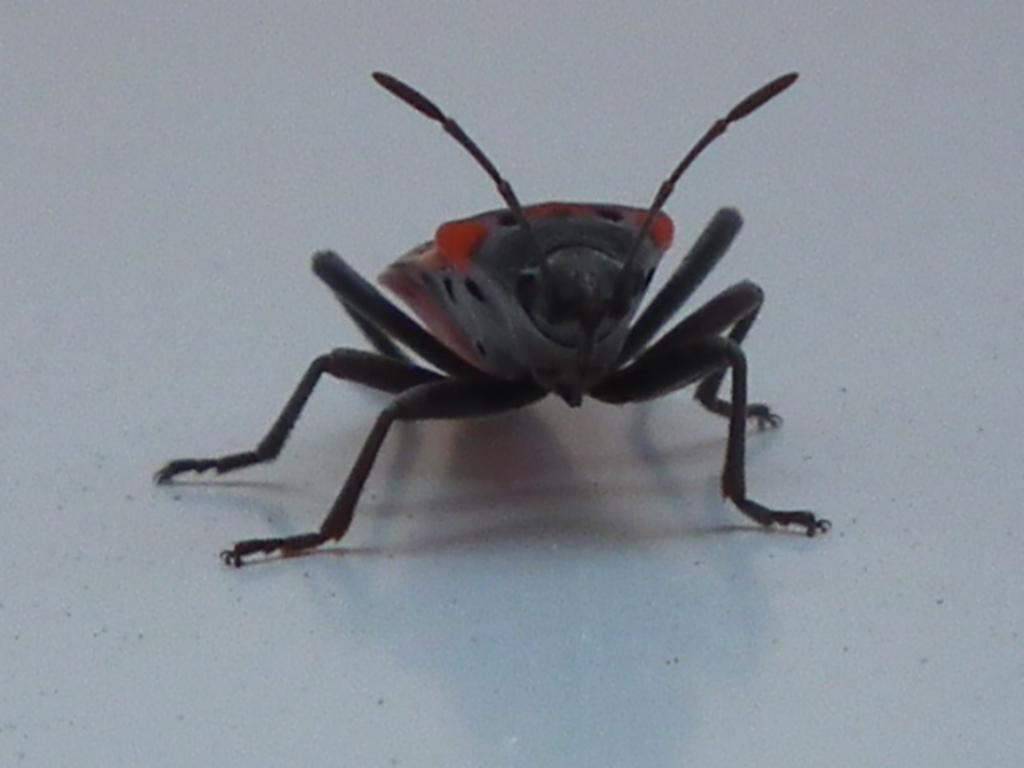What type of creature can be seen in the image? There is an insect in the image. What is the insect standing on? The insect is on a white color platform. How many women are participating in the show with the snail in the image? There is no show or snail present in the image; it features an insect on a white color platform. 